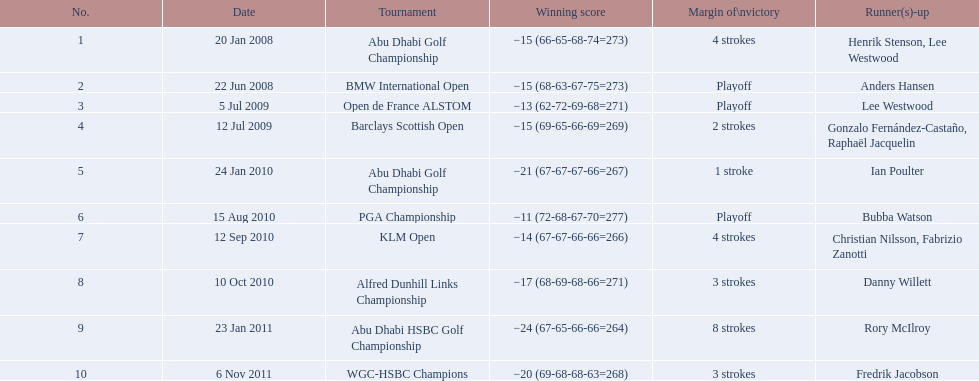What is the disparity in the number of strokes in the klm open and the barclays scottish open? 2 strokes. 